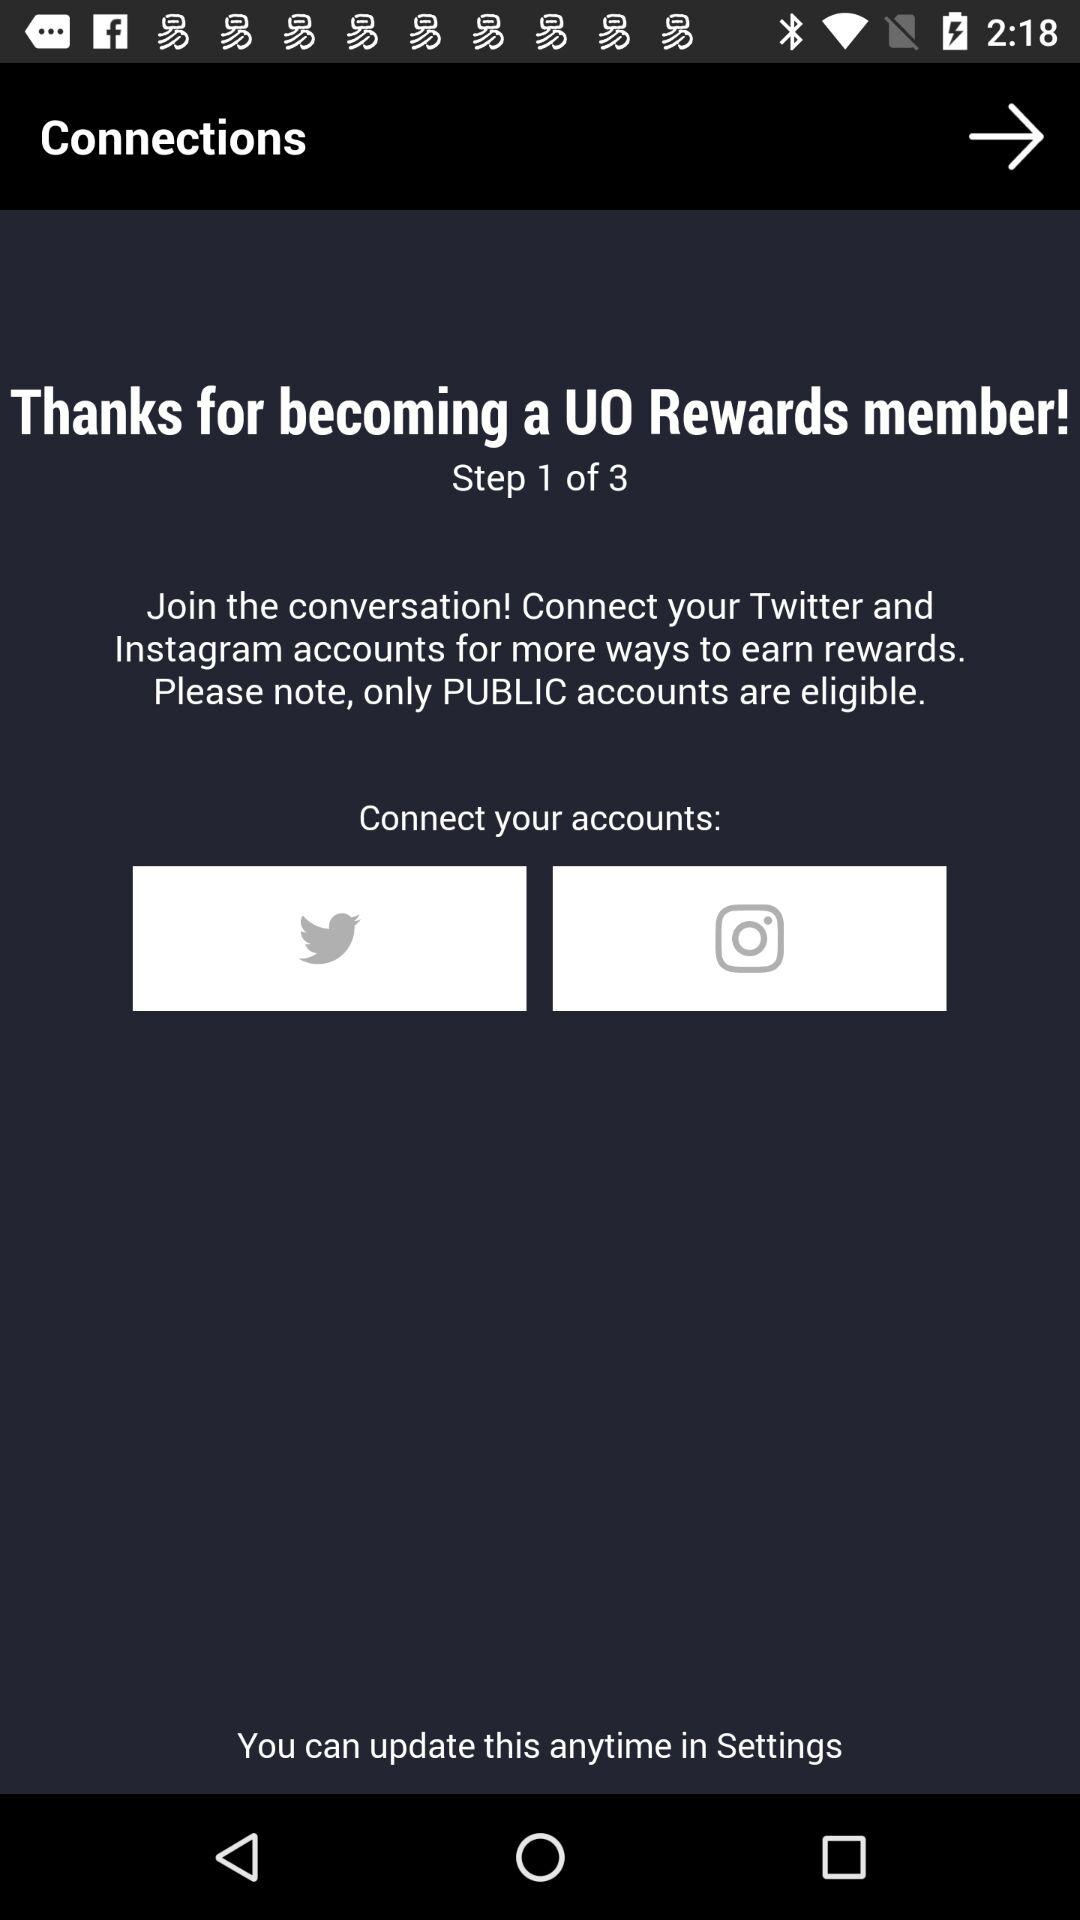What account names can we connect for more ways to earn rewards? You can connect your "Twitter" and "Instagram" accounts. 